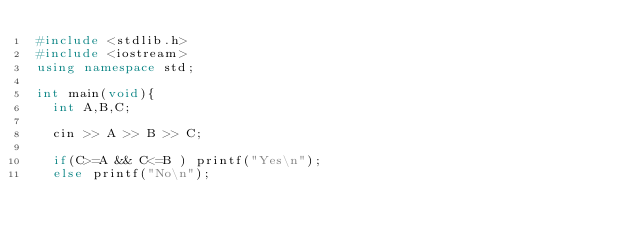Convert code to text. <code><loc_0><loc_0><loc_500><loc_500><_C++_>#include <stdlib.h>
#include <iostream>
using namespace std;

int main(void){
  int A,B,C;
  
  cin >> A >> B >> C;
  
  if(C>=A && C<=B ) printf("Yes\n");
  else printf("No\n");
  </code> 